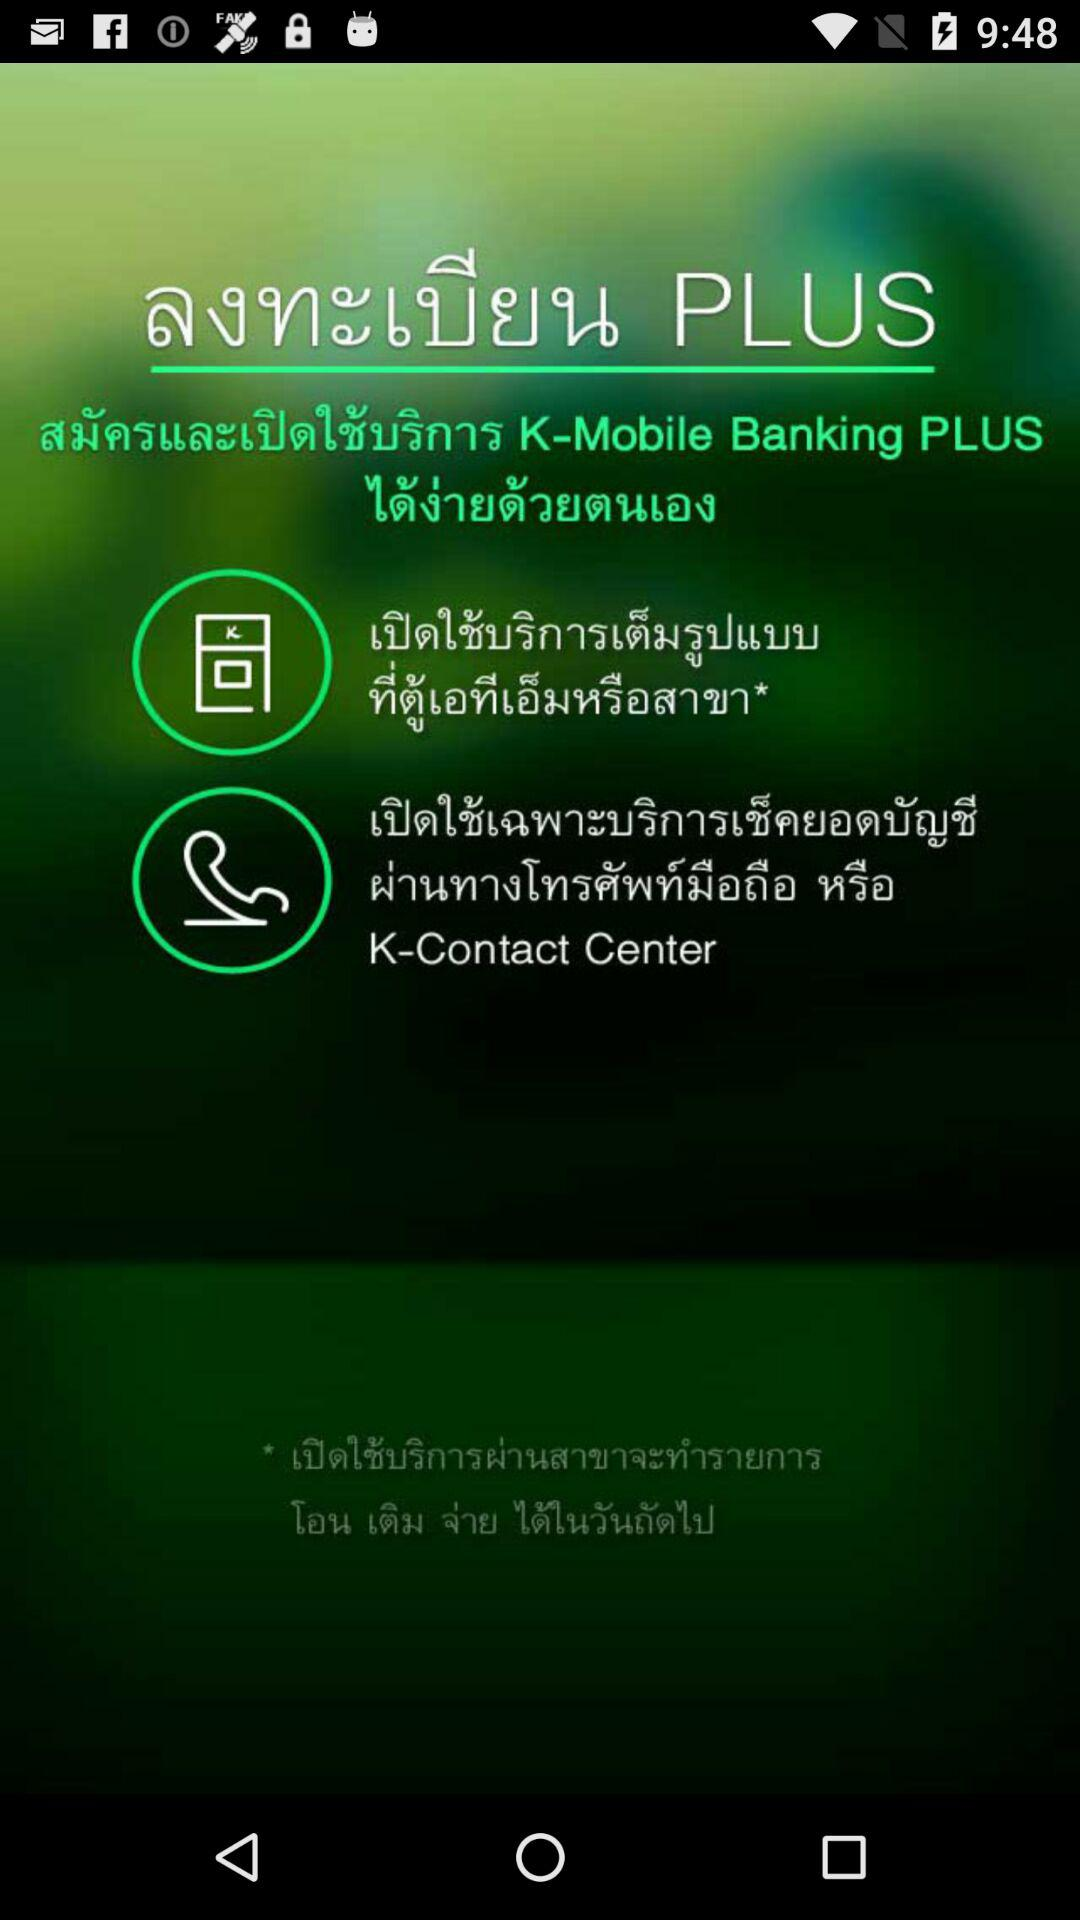How many ways can I open a full-service account?
Answer the question using a single word or phrase. 2 